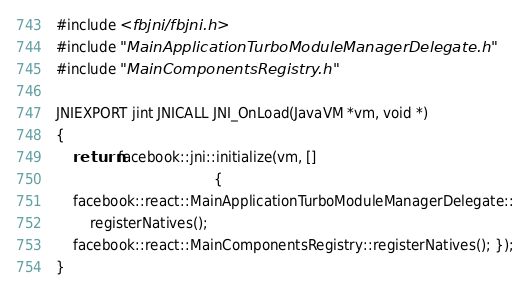<code> <loc_0><loc_0><loc_500><loc_500><_C_>#include <fbjni/fbjni.h>
#include "MainApplicationTurboModuleManagerDelegate.h"
#include "MainComponentsRegistry.h"

JNIEXPORT jint JNICALL JNI_OnLoad(JavaVM *vm, void *)
{
    return facebook::jni::initialize(vm, []
                                     {
    facebook::react::MainApplicationTurboModuleManagerDelegate::
        registerNatives();
    facebook::react::MainComponentsRegistry::registerNatives(); });
}</code> 